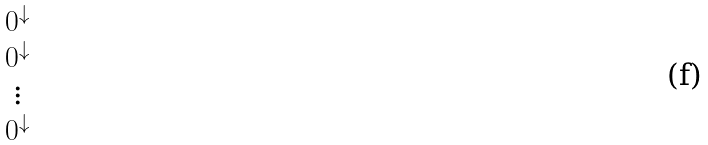<formula> <loc_0><loc_0><loc_500><loc_500>\begin{matrix} 0 ^ { \downarrow } \\ 0 ^ { \downarrow } \\ \vdots \\ 0 ^ { \downarrow } \end{matrix}</formula> 